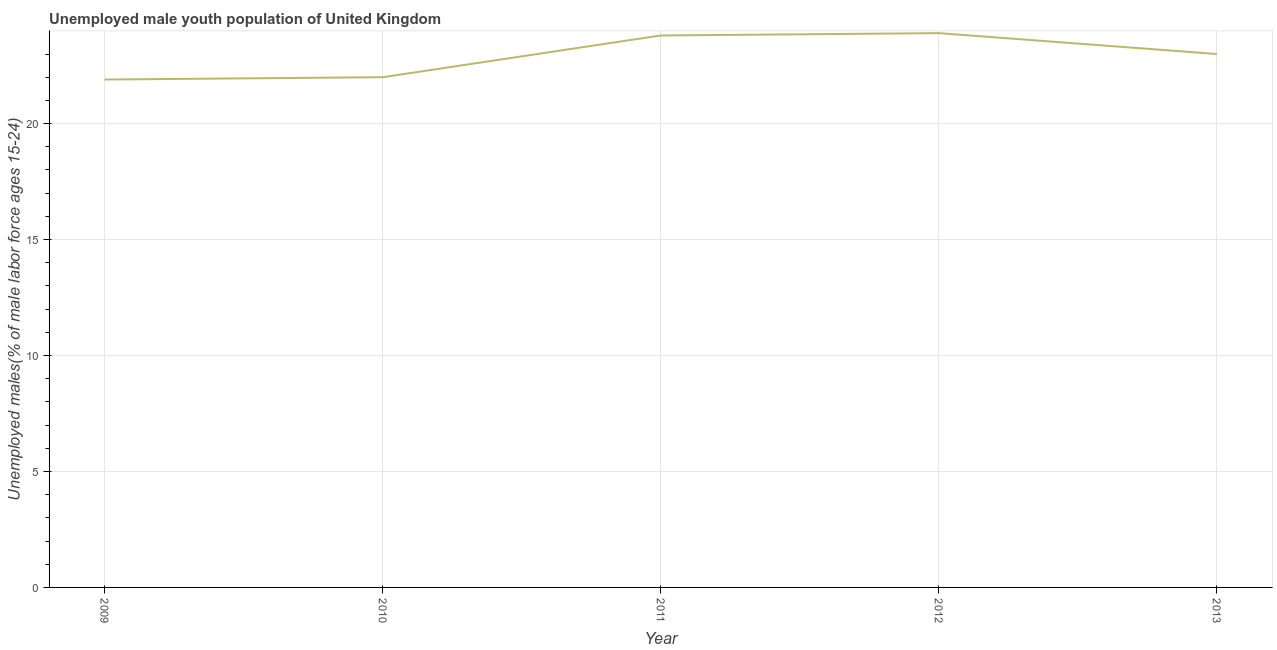What is the unemployed male youth in 2013?
Provide a short and direct response. 23. Across all years, what is the maximum unemployed male youth?
Offer a very short reply. 23.9. Across all years, what is the minimum unemployed male youth?
Ensure brevity in your answer.  21.9. In which year was the unemployed male youth maximum?
Make the answer very short. 2012. What is the sum of the unemployed male youth?
Your answer should be compact. 114.6. What is the difference between the unemployed male youth in 2010 and 2011?
Ensure brevity in your answer.  -1.8. What is the average unemployed male youth per year?
Keep it short and to the point. 22.92. What is the median unemployed male youth?
Ensure brevity in your answer.  23. In how many years, is the unemployed male youth greater than 1 %?
Provide a succinct answer. 5. What is the ratio of the unemployed male youth in 2011 to that in 2013?
Provide a succinct answer. 1.03. Is the difference between the unemployed male youth in 2010 and 2012 greater than the difference between any two years?
Provide a short and direct response. No. What is the difference between the highest and the second highest unemployed male youth?
Ensure brevity in your answer.  0.1. Is the sum of the unemployed male youth in 2010 and 2013 greater than the maximum unemployed male youth across all years?
Provide a succinct answer. Yes. In how many years, is the unemployed male youth greater than the average unemployed male youth taken over all years?
Offer a very short reply. 3. How many lines are there?
Make the answer very short. 1. How many years are there in the graph?
Offer a very short reply. 5. What is the difference between two consecutive major ticks on the Y-axis?
Your response must be concise. 5. Does the graph contain grids?
Keep it short and to the point. Yes. What is the title of the graph?
Your answer should be compact. Unemployed male youth population of United Kingdom. What is the label or title of the Y-axis?
Your answer should be compact. Unemployed males(% of male labor force ages 15-24). What is the Unemployed males(% of male labor force ages 15-24) in 2009?
Your answer should be very brief. 21.9. What is the Unemployed males(% of male labor force ages 15-24) of 2011?
Your response must be concise. 23.8. What is the Unemployed males(% of male labor force ages 15-24) of 2012?
Give a very brief answer. 23.9. What is the difference between the Unemployed males(% of male labor force ages 15-24) in 2009 and 2010?
Ensure brevity in your answer.  -0.1. What is the difference between the Unemployed males(% of male labor force ages 15-24) in 2009 and 2011?
Provide a short and direct response. -1.9. What is the difference between the Unemployed males(% of male labor force ages 15-24) in 2009 and 2012?
Provide a succinct answer. -2. What is the difference between the Unemployed males(% of male labor force ages 15-24) in 2010 and 2011?
Your answer should be compact. -1.8. What is the difference between the Unemployed males(% of male labor force ages 15-24) in 2010 and 2012?
Provide a short and direct response. -1.9. What is the difference between the Unemployed males(% of male labor force ages 15-24) in 2010 and 2013?
Offer a very short reply. -1. What is the ratio of the Unemployed males(% of male labor force ages 15-24) in 2009 to that in 2010?
Provide a succinct answer. 0.99. What is the ratio of the Unemployed males(% of male labor force ages 15-24) in 2009 to that in 2011?
Offer a terse response. 0.92. What is the ratio of the Unemployed males(% of male labor force ages 15-24) in 2009 to that in 2012?
Ensure brevity in your answer.  0.92. What is the ratio of the Unemployed males(% of male labor force ages 15-24) in 2010 to that in 2011?
Offer a terse response. 0.92. What is the ratio of the Unemployed males(% of male labor force ages 15-24) in 2010 to that in 2012?
Your answer should be compact. 0.92. What is the ratio of the Unemployed males(% of male labor force ages 15-24) in 2010 to that in 2013?
Provide a short and direct response. 0.96. What is the ratio of the Unemployed males(% of male labor force ages 15-24) in 2011 to that in 2013?
Your response must be concise. 1.03. What is the ratio of the Unemployed males(% of male labor force ages 15-24) in 2012 to that in 2013?
Your response must be concise. 1.04. 